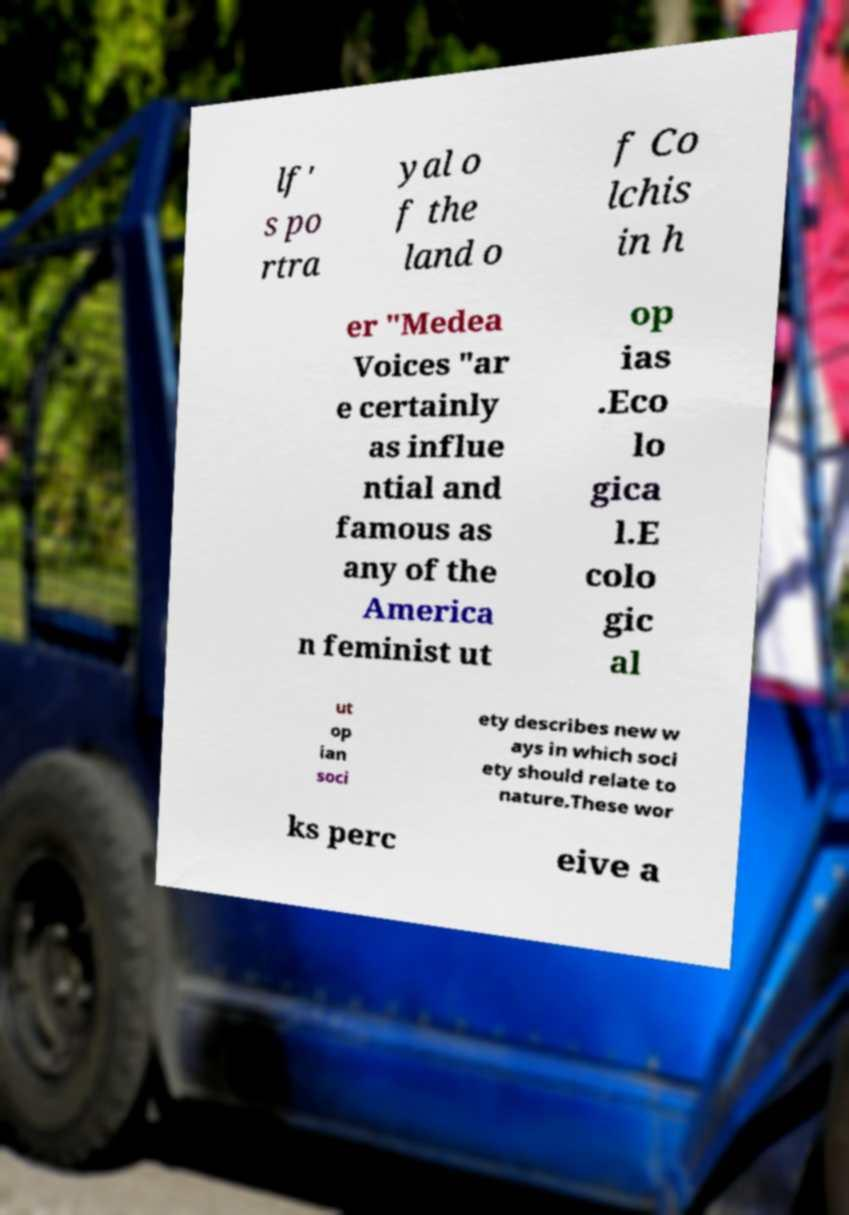Could you assist in decoding the text presented in this image and type it out clearly? lf' s po rtra yal o f the land o f Co lchis in h er "Medea Voices "ar e certainly as influe ntial and famous as any of the America n feminist ut op ias .Eco lo gica l.E colo gic al ut op ian soci ety describes new w ays in which soci ety should relate to nature.These wor ks perc eive a 